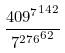Convert formula to latex. <formula><loc_0><loc_0><loc_500><loc_500>\frac { { 4 0 9 ^ { 7 } } ^ { 1 4 2 } } { { 7 ^ { 2 7 6 } } ^ { 6 2 } }</formula> 